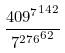Convert formula to latex. <formula><loc_0><loc_0><loc_500><loc_500>\frac { { 4 0 9 ^ { 7 } } ^ { 1 4 2 } } { { 7 ^ { 2 7 6 } } ^ { 6 2 } }</formula> 